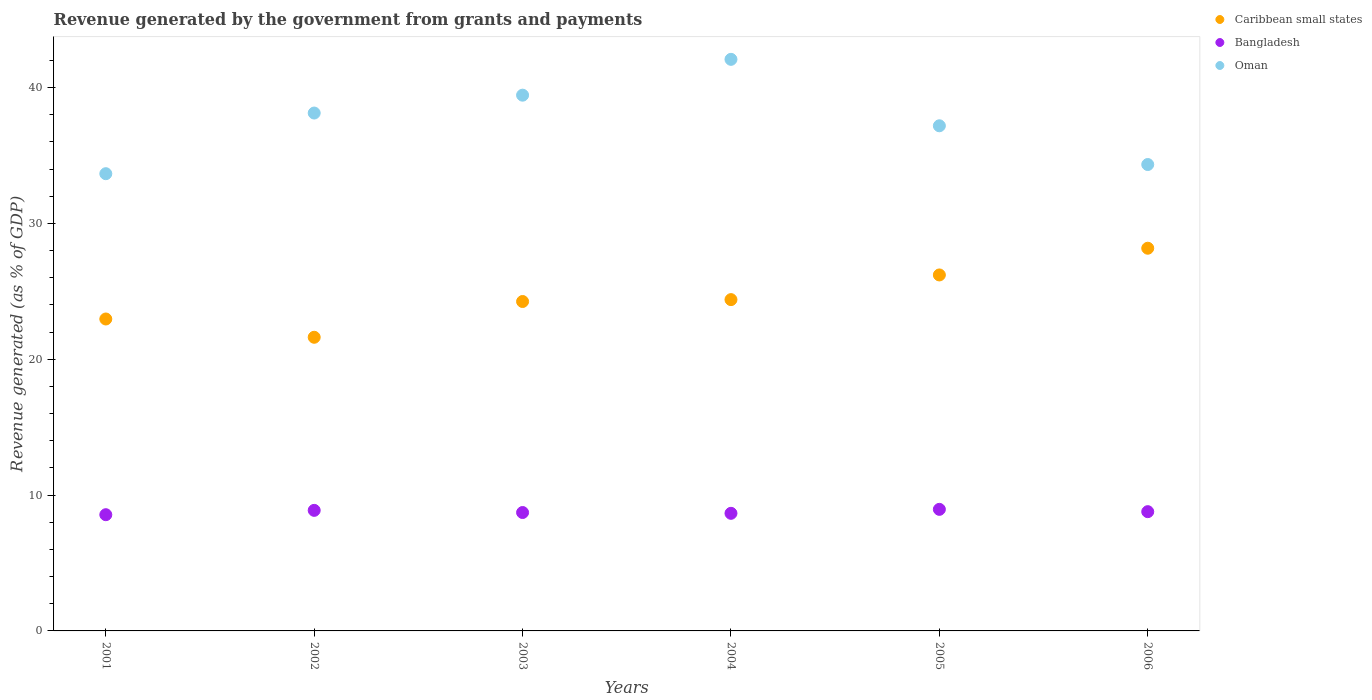How many different coloured dotlines are there?
Offer a terse response. 3. Is the number of dotlines equal to the number of legend labels?
Keep it short and to the point. Yes. What is the revenue generated by the government in Caribbean small states in 2004?
Give a very brief answer. 24.39. Across all years, what is the maximum revenue generated by the government in Oman?
Provide a short and direct response. 42.07. Across all years, what is the minimum revenue generated by the government in Caribbean small states?
Your answer should be very brief. 21.62. In which year was the revenue generated by the government in Oman minimum?
Your answer should be very brief. 2001. What is the total revenue generated by the government in Caribbean small states in the graph?
Provide a succinct answer. 147.59. What is the difference between the revenue generated by the government in Caribbean small states in 2005 and that in 2006?
Ensure brevity in your answer.  -1.97. What is the difference between the revenue generated by the government in Oman in 2001 and the revenue generated by the government in Bangladesh in 2005?
Provide a short and direct response. 24.71. What is the average revenue generated by the government in Bangladesh per year?
Ensure brevity in your answer.  8.75. In the year 2005, what is the difference between the revenue generated by the government in Bangladesh and revenue generated by the government in Caribbean small states?
Your response must be concise. -17.25. In how many years, is the revenue generated by the government in Oman greater than 12 %?
Give a very brief answer. 6. What is the ratio of the revenue generated by the government in Bangladesh in 2002 to that in 2006?
Your response must be concise. 1.01. Is the revenue generated by the government in Caribbean small states in 2003 less than that in 2005?
Provide a short and direct response. Yes. Is the difference between the revenue generated by the government in Bangladesh in 2003 and 2005 greater than the difference between the revenue generated by the government in Caribbean small states in 2003 and 2005?
Keep it short and to the point. Yes. What is the difference between the highest and the second highest revenue generated by the government in Caribbean small states?
Your response must be concise. 1.97. What is the difference between the highest and the lowest revenue generated by the government in Oman?
Make the answer very short. 8.42. Is it the case that in every year, the sum of the revenue generated by the government in Bangladesh and revenue generated by the government in Caribbean small states  is greater than the revenue generated by the government in Oman?
Make the answer very short. No. Does the revenue generated by the government in Caribbean small states monotonically increase over the years?
Your answer should be compact. No. How many years are there in the graph?
Your response must be concise. 6. Are the values on the major ticks of Y-axis written in scientific E-notation?
Ensure brevity in your answer.  No. What is the title of the graph?
Give a very brief answer. Revenue generated by the government from grants and payments. Does "Sub-Saharan Africa (developing only)" appear as one of the legend labels in the graph?
Give a very brief answer. No. What is the label or title of the Y-axis?
Provide a short and direct response. Revenue generated (as % of GDP). What is the Revenue generated (as % of GDP) in Caribbean small states in 2001?
Offer a very short reply. 22.96. What is the Revenue generated (as % of GDP) of Bangladesh in 2001?
Your response must be concise. 8.56. What is the Revenue generated (as % of GDP) in Oman in 2001?
Provide a short and direct response. 33.66. What is the Revenue generated (as % of GDP) of Caribbean small states in 2002?
Offer a terse response. 21.62. What is the Revenue generated (as % of GDP) in Bangladesh in 2002?
Give a very brief answer. 8.87. What is the Revenue generated (as % of GDP) of Oman in 2002?
Your answer should be very brief. 38.12. What is the Revenue generated (as % of GDP) in Caribbean small states in 2003?
Keep it short and to the point. 24.25. What is the Revenue generated (as % of GDP) of Bangladesh in 2003?
Your answer should be very brief. 8.72. What is the Revenue generated (as % of GDP) in Oman in 2003?
Ensure brevity in your answer.  39.44. What is the Revenue generated (as % of GDP) of Caribbean small states in 2004?
Offer a very short reply. 24.39. What is the Revenue generated (as % of GDP) of Bangladesh in 2004?
Offer a very short reply. 8.66. What is the Revenue generated (as % of GDP) of Oman in 2004?
Give a very brief answer. 42.07. What is the Revenue generated (as % of GDP) of Caribbean small states in 2005?
Ensure brevity in your answer.  26.2. What is the Revenue generated (as % of GDP) of Bangladesh in 2005?
Your answer should be very brief. 8.95. What is the Revenue generated (as % of GDP) of Oman in 2005?
Your response must be concise. 37.18. What is the Revenue generated (as % of GDP) of Caribbean small states in 2006?
Make the answer very short. 28.17. What is the Revenue generated (as % of GDP) of Bangladesh in 2006?
Provide a succinct answer. 8.78. What is the Revenue generated (as % of GDP) of Oman in 2006?
Offer a very short reply. 34.33. Across all years, what is the maximum Revenue generated (as % of GDP) in Caribbean small states?
Give a very brief answer. 28.17. Across all years, what is the maximum Revenue generated (as % of GDP) in Bangladesh?
Offer a very short reply. 8.95. Across all years, what is the maximum Revenue generated (as % of GDP) in Oman?
Offer a very short reply. 42.07. Across all years, what is the minimum Revenue generated (as % of GDP) in Caribbean small states?
Ensure brevity in your answer.  21.62. Across all years, what is the minimum Revenue generated (as % of GDP) of Bangladesh?
Make the answer very short. 8.56. Across all years, what is the minimum Revenue generated (as % of GDP) of Oman?
Keep it short and to the point. 33.66. What is the total Revenue generated (as % of GDP) of Caribbean small states in the graph?
Give a very brief answer. 147.59. What is the total Revenue generated (as % of GDP) of Bangladesh in the graph?
Provide a succinct answer. 52.53. What is the total Revenue generated (as % of GDP) in Oman in the graph?
Offer a terse response. 224.81. What is the difference between the Revenue generated (as % of GDP) of Caribbean small states in 2001 and that in 2002?
Make the answer very short. 1.35. What is the difference between the Revenue generated (as % of GDP) of Bangladesh in 2001 and that in 2002?
Keep it short and to the point. -0.32. What is the difference between the Revenue generated (as % of GDP) in Oman in 2001 and that in 2002?
Provide a short and direct response. -4.46. What is the difference between the Revenue generated (as % of GDP) of Caribbean small states in 2001 and that in 2003?
Provide a short and direct response. -1.29. What is the difference between the Revenue generated (as % of GDP) of Bangladesh in 2001 and that in 2003?
Make the answer very short. -0.16. What is the difference between the Revenue generated (as % of GDP) of Oman in 2001 and that in 2003?
Provide a short and direct response. -5.78. What is the difference between the Revenue generated (as % of GDP) in Caribbean small states in 2001 and that in 2004?
Provide a short and direct response. -1.43. What is the difference between the Revenue generated (as % of GDP) in Bangladesh in 2001 and that in 2004?
Your answer should be compact. -0.1. What is the difference between the Revenue generated (as % of GDP) in Oman in 2001 and that in 2004?
Offer a terse response. -8.42. What is the difference between the Revenue generated (as % of GDP) in Caribbean small states in 2001 and that in 2005?
Ensure brevity in your answer.  -3.24. What is the difference between the Revenue generated (as % of GDP) in Bangladesh in 2001 and that in 2005?
Your answer should be very brief. -0.39. What is the difference between the Revenue generated (as % of GDP) in Oman in 2001 and that in 2005?
Ensure brevity in your answer.  -3.53. What is the difference between the Revenue generated (as % of GDP) in Caribbean small states in 2001 and that in 2006?
Offer a very short reply. -5.21. What is the difference between the Revenue generated (as % of GDP) in Bangladesh in 2001 and that in 2006?
Your response must be concise. -0.22. What is the difference between the Revenue generated (as % of GDP) of Oman in 2001 and that in 2006?
Your response must be concise. -0.68. What is the difference between the Revenue generated (as % of GDP) of Caribbean small states in 2002 and that in 2003?
Offer a terse response. -2.63. What is the difference between the Revenue generated (as % of GDP) of Bangladesh in 2002 and that in 2003?
Provide a short and direct response. 0.16. What is the difference between the Revenue generated (as % of GDP) of Oman in 2002 and that in 2003?
Offer a very short reply. -1.32. What is the difference between the Revenue generated (as % of GDP) of Caribbean small states in 2002 and that in 2004?
Offer a terse response. -2.77. What is the difference between the Revenue generated (as % of GDP) of Bangladesh in 2002 and that in 2004?
Your response must be concise. 0.22. What is the difference between the Revenue generated (as % of GDP) of Oman in 2002 and that in 2004?
Provide a short and direct response. -3.95. What is the difference between the Revenue generated (as % of GDP) in Caribbean small states in 2002 and that in 2005?
Offer a very short reply. -4.59. What is the difference between the Revenue generated (as % of GDP) in Bangladesh in 2002 and that in 2005?
Make the answer very short. -0.07. What is the difference between the Revenue generated (as % of GDP) of Oman in 2002 and that in 2005?
Your response must be concise. 0.94. What is the difference between the Revenue generated (as % of GDP) of Caribbean small states in 2002 and that in 2006?
Provide a short and direct response. -6.55. What is the difference between the Revenue generated (as % of GDP) of Bangladesh in 2002 and that in 2006?
Offer a terse response. 0.1. What is the difference between the Revenue generated (as % of GDP) in Oman in 2002 and that in 2006?
Your answer should be compact. 3.79. What is the difference between the Revenue generated (as % of GDP) in Caribbean small states in 2003 and that in 2004?
Provide a succinct answer. -0.14. What is the difference between the Revenue generated (as % of GDP) in Bangladesh in 2003 and that in 2004?
Provide a short and direct response. 0.06. What is the difference between the Revenue generated (as % of GDP) in Oman in 2003 and that in 2004?
Your response must be concise. -2.64. What is the difference between the Revenue generated (as % of GDP) of Caribbean small states in 2003 and that in 2005?
Your answer should be compact. -1.96. What is the difference between the Revenue generated (as % of GDP) of Bangladesh in 2003 and that in 2005?
Provide a succinct answer. -0.23. What is the difference between the Revenue generated (as % of GDP) of Oman in 2003 and that in 2005?
Offer a terse response. 2.25. What is the difference between the Revenue generated (as % of GDP) in Caribbean small states in 2003 and that in 2006?
Offer a very short reply. -3.92. What is the difference between the Revenue generated (as % of GDP) of Bangladesh in 2003 and that in 2006?
Offer a terse response. -0.06. What is the difference between the Revenue generated (as % of GDP) in Oman in 2003 and that in 2006?
Provide a short and direct response. 5.11. What is the difference between the Revenue generated (as % of GDP) in Caribbean small states in 2004 and that in 2005?
Your response must be concise. -1.82. What is the difference between the Revenue generated (as % of GDP) in Bangladesh in 2004 and that in 2005?
Your answer should be very brief. -0.29. What is the difference between the Revenue generated (as % of GDP) in Oman in 2004 and that in 2005?
Offer a terse response. 4.89. What is the difference between the Revenue generated (as % of GDP) of Caribbean small states in 2004 and that in 2006?
Offer a terse response. -3.78. What is the difference between the Revenue generated (as % of GDP) in Bangladesh in 2004 and that in 2006?
Offer a very short reply. -0.12. What is the difference between the Revenue generated (as % of GDP) of Oman in 2004 and that in 2006?
Give a very brief answer. 7.74. What is the difference between the Revenue generated (as % of GDP) in Caribbean small states in 2005 and that in 2006?
Offer a terse response. -1.97. What is the difference between the Revenue generated (as % of GDP) of Bangladesh in 2005 and that in 2006?
Your response must be concise. 0.17. What is the difference between the Revenue generated (as % of GDP) in Oman in 2005 and that in 2006?
Your answer should be very brief. 2.85. What is the difference between the Revenue generated (as % of GDP) in Caribbean small states in 2001 and the Revenue generated (as % of GDP) in Bangladesh in 2002?
Keep it short and to the point. 14.09. What is the difference between the Revenue generated (as % of GDP) of Caribbean small states in 2001 and the Revenue generated (as % of GDP) of Oman in 2002?
Provide a succinct answer. -15.16. What is the difference between the Revenue generated (as % of GDP) in Bangladesh in 2001 and the Revenue generated (as % of GDP) in Oman in 2002?
Provide a short and direct response. -29.57. What is the difference between the Revenue generated (as % of GDP) of Caribbean small states in 2001 and the Revenue generated (as % of GDP) of Bangladesh in 2003?
Your answer should be very brief. 14.25. What is the difference between the Revenue generated (as % of GDP) in Caribbean small states in 2001 and the Revenue generated (as % of GDP) in Oman in 2003?
Offer a very short reply. -16.48. What is the difference between the Revenue generated (as % of GDP) in Bangladesh in 2001 and the Revenue generated (as % of GDP) in Oman in 2003?
Offer a very short reply. -30.88. What is the difference between the Revenue generated (as % of GDP) of Caribbean small states in 2001 and the Revenue generated (as % of GDP) of Bangladesh in 2004?
Make the answer very short. 14.3. What is the difference between the Revenue generated (as % of GDP) of Caribbean small states in 2001 and the Revenue generated (as % of GDP) of Oman in 2004?
Ensure brevity in your answer.  -19.11. What is the difference between the Revenue generated (as % of GDP) in Bangladesh in 2001 and the Revenue generated (as % of GDP) in Oman in 2004?
Make the answer very short. -33.52. What is the difference between the Revenue generated (as % of GDP) in Caribbean small states in 2001 and the Revenue generated (as % of GDP) in Bangladesh in 2005?
Give a very brief answer. 14.01. What is the difference between the Revenue generated (as % of GDP) of Caribbean small states in 2001 and the Revenue generated (as % of GDP) of Oman in 2005?
Ensure brevity in your answer.  -14.22. What is the difference between the Revenue generated (as % of GDP) in Bangladesh in 2001 and the Revenue generated (as % of GDP) in Oman in 2005?
Make the answer very short. -28.63. What is the difference between the Revenue generated (as % of GDP) in Caribbean small states in 2001 and the Revenue generated (as % of GDP) in Bangladesh in 2006?
Your response must be concise. 14.18. What is the difference between the Revenue generated (as % of GDP) of Caribbean small states in 2001 and the Revenue generated (as % of GDP) of Oman in 2006?
Keep it short and to the point. -11.37. What is the difference between the Revenue generated (as % of GDP) of Bangladesh in 2001 and the Revenue generated (as % of GDP) of Oman in 2006?
Your answer should be compact. -25.78. What is the difference between the Revenue generated (as % of GDP) in Caribbean small states in 2002 and the Revenue generated (as % of GDP) in Bangladesh in 2003?
Provide a short and direct response. 12.9. What is the difference between the Revenue generated (as % of GDP) of Caribbean small states in 2002 and the Revenue generated (as % of GDP) of Oman in 2003?
Make the answer very short. -17.82. What is the difference between the Revenue generated (as % of GDP) in Bangladesh in 2002 and the Revenue generated (as % of GDP) in Oman in 2003?
Give a very brief answer. -30.56. What is the difference between the Revenue generated (as % of GDP) in Caribbean small states in 2002 and the Revenue generated (as % of GDP) in Bangladesh in 2004?
Make the answer very short. 12.96. What is the difference between the Revenue generated (as % of GDP) of Caribbean small states in 2002 and the Revenue generated (as % of GDP) of Oman in 2004?
Keep it short and to the point. -20.46. What is the difference between the Revenue generated (as % of GDP) in Bangladesh in 2002 and the Revenue generated (as % of GDP) in Oman in 2004?
Ensure brevity in your answer.  -33.2. What is the difference between the Revenue generated (as % of GDP) in Caribbean small states in 2002 and the Revenue generated (as % of GDP) in Bangladesh in 2005?
Offer a very short reply. 12.67. What is the difference between the Revenue generated (as % of GDP) in Caribbean small states in 2002 and the Revenue generated (as % of GDP) in Oman in 2005?
Provide a short and direct response. -15.57. What is the difference between the Revenue generated (as % of GDP) in Bangladesh in 2002 and the Revenue generated (as % of GDP) in Oman in 2005?
Ensure brevity in your answer.  -28.31. What is the difference between the Revenue generated (as % of GDP) of Caribbean small states in 2002 and the Revenue generated (as % of GDP) of Bangladesh in 2006?
Offer a terse response. 12.84. What is the difference between the Revenue generated (as % of GDP) in Caribbean small states in 2002 and the Revenue generated (as % of GDP) in Oman in 2006?
Keep it short and to the point. -12.72. What is the difference between the Revenue generated (as % of GDP) of Bangladesh in 2002 and the Revenue generated (as % of GDP) of Oman in 2006?
Offer a very short reply. -25.46. What is the difference between the Revenue generated (as % of GDP) of Caribbean small states in 2003 and the Revenue generated (as % of GDP) of Bangladesh in 2004?
Your answer should be very brief. 15.59. What is the difference between the Revenue generated (as % of GDP) of Caribbean small states in 2003 and the Revenue generated (as % of GDP) of Oman in 2004?
Make the answer very short. -17.83. What is the difference between the Revenue generated (as % of GDP) in Bangladesh in 2003 and the Revenue generated (as % of GDP) in Oman in 2004?
Provide a succinct answer. -33.36. What is the difference between the Revenue generated (as % of GDP) in Caribbean small states in 2003 and the Revenue generated (as % of GDP) in Bangladesh in 2005?
Provide a succinct answer. 15.3. What is the difference between the Revenue generated (as % of GDP) in Caribbean small states in 2003 and the Revenue generated (as % of GDP) in Oman in 2005?
Your answer should be compact. -12.93. What is the difference between the Revenue generated (as % of GDP) of Bangladesh in 2003 and the Revenue generated (as % of GDP) of Oman in 2005?
Make the answer very short. -28.47. What is the difference between the Revenue generated (as % of GDP) of Caribbean small states in 2003 and the Revenue generated (as % of GDP) of Bangladesh in 2006?
Provide a short and direct response. 15.47. What is the difference between the Revenue generated (as % of GDP) in Caribbean small states in 2003 and the Revenue generated (as % of GDP) in Oman in 2006?
Your answer should be compact. -10.08. What is the difference between the Revenue generated (as % of GDP) in Bangladesh in 2003 and the Revenue generated (as % of GDP) in Oman in 2006?
Your answer should be very brief. -25.62. What is the difference between the Revenue generated (as % of GDP) of Caribbean small states in 2004 and the Revenue generated (as % of GDP) of Bangladesh in 2005?
Keep it short and to the point. 15.44. What is the difference between the Revenue generated (as % of GDP) in Caribbean small states in 2004 and the Revenue generated (as % of GDP) in Oman in 2005?
Your answer should be compact. -12.8. What is the difference between the Revenue generated (as % of GDP) in Bangladesh in 2004 and the Revenue generated (as % of GDP) in Oman in 2005?
Ensure brevity in your answer.  -28.53. What is the difference between the Revenue generated (as % of GDP) of Caribbean small states in 2004 and the Revenue generated (as % of GDP) of Bangladesh in 2006?
Offer a terse response. 15.61. What is the difference between the Revenue generated (as % of GDP) of Caribbean small states in 2004 and the Revenue generated (as % of GDP) of Oman in 2006?
Your answer should be compact. -9.94. What is the difference between the Revenue generated (as % of GDP) in Bangladesh in 2004 and the Revenue generated (as % of GDP) in Oman in 2006?
Offer a terse response. -25.68. What is the difference between the Revenue generated (as % of GDP) in Caribbean small states in 2005 and the Revenue generated (as % of GDP) in Bangladesh in 2006?
Offer a terse response. 17.43. What is the difference between the Revenue generated (as % of GDP) in Caribbean small states in 2005 and the Revenue generated (as % of GDP) in Oman in 2006?
Your answer should be very brief. -8.13. What is the difference between the Revenue generated (as % of GDP) in Bangladesh in 2005 and the Revenue generated (as % of GDP) in Oman in 2006?
Your response must be concise. -25.38. What is the average Revenue generated (as % of GDP) of Caribbean small states per year?
Your answer should be compact. 24.6. What is the average Revenue generated (as % of GDP) of Bangladesh per year?
Give a very brief answer. 8.75. What is the average Revenue generated (as % of GDP) in Oman per year?
Ensure brevity in your answer.  37.47. In the year 2001, what is the difference between the Revenue generated (as % of GDP) of Caribbean small states and Revenue generated (as % of GDP) of Bangladesh?
Give a very brief answer. 14.41. In the year 2001, what is the difference between the Revenue generated (as % of GDP) in Caribbean small states and Revenue generated (as % of GDP) in Oman?
Provide a short and direct response. -10.7. In the year 2001, what is the difference between the Revenue generated (as % of GDP) in Bangladesh and Revenue generated (as % of GDP) in Oman?
Give a very brief answer. -25.1. In the year 2002, what is the difference between the Revenue generated (as % of GDP) in Caribbean small states and Revenue generated (as % of GDP) in Bangladesh?
Your answer should be very brief. 12.74. In the year 2002, what is the difference between the Revenue generated (as % of GDP) of Caribbean small states and Revenue generated (as % of GDP) of Oman?
Your response must be concise. -16.51. In the year 2002, what is the difference between the Revenue generated (as % of GDP) in Bangladesh and Revenue generated (as % of GDP) in Oman?
Give a very brief answer. -29.25. In the year 2003, what is the difference between the Revenue generated (as % of GDP) in Caribbean small states and Revenue generated (as % of GDP) in Bangladesh?
Provide a short and direct response. 15.53. In the year 2003, what is the difference between the Revenue generated (as % of GDP) in Caribbean small states and Revenue generated (as % of GDP) in Oman?
Keep it short and to the point. -15.19. In the year 2003, what is the difference between the Revenue generated (as % of GDP) in Bangladesh and Revenue generated (as % of GDP) in Oman?
Offer a very short reply. -30.72. In the year 2004, what is the difference between the Revenue generated (as % of GDP) of Caribbean small states and Revenue generated (as % of GDP) of Bangladesh?
Your answer should be very brief. 15.73. In the year 2004, what is the difference between the Revenue generated (as % of GDP) of Caribbean small states and Revenue generated (as % of GDP) of Oman?
Give a very brief answer. -17.69. In the year 2004, what is the difference between the Revenue generated (as % of GDP) of Bangladesh and Revenue generated (as % of GDP) of Oman?
Your answer should be very brief. -33.42. In the year 2005, what is the difference between the Revenue generated (as % of GDP) in Caribbean small states and Revenue generated (as % of GDP) in Bangladesh?
Offer a terse response. 17.25. In the year 2005, what is the difference between the Revenue generated (as % of GDP) of Caribbean small states and Revenue generated (as % of GDP) of Oman?
Your answer should be very brief. -10.98. In the year 2005, what is the difference between the Revenue generated (as % of GDP) in Bangladesh and Revenue generated (as % of GDP) in Oman?
Your response must be concise. -28.23. In the year 2006, what is the difference between the Revenue generated (as % of GDP) in Caribbean small states and Revenue generated (as % of GDP) in Bangladesh?
Make the answer very short. 19.39. In the year 2006, what is the difference between the Revenue generated (as % of GDP) of Caribbean small states and Revenue generated (as % of GDP) of Oman?
Offer a very short reply. -6.16. In the year 2006, what is the difference between the Revenue generated (as % of GDP) in Bangladesh and Revenue generated (as % of GDP) in Oman?
Give a very brief answer. -25.55. What is the ratio of the Revenue generated (as % of GDP) in Caribbean small states in 2001 to that in 2002?
Your response must be concise. 1.06. What is the ratio of the Revenue generated (as % of GDP) of Oman in 2001 to that in 2002?
Give a very brief answer. 0.88. What is the ratio of the Revenue generated (as % of GDP) in Caribbean small states in 2001 to that in 2003?
Offer a terse response. 0.95. What is the ratio of the Revenue generated (as % of GDP) of Bangladesh in 2001 to that in 2003?
Provide a succinct answer. 0.98. What is the ratio of the Revenue generated (as % of GDP) of Oman in 2001 to that in 2003?
Provide a succinct answer. 0.85. What is the ratio of the Revenue generated (as % of GDP) of Caribbean small states in 2001 to that in 2004?
Your answer should be compact. 0.94. What is the ratio of the Revenue generated (as % of GDP) in Bangladesh in 2001 to that in 2004?
Offer a very short reply. 0.99. What is the ratio of the Revenue generated (as % of GDP) of Oman in 2001 to that in 2004?
Provide a succinct answer. 0.8. What is the ratio of the Revenue generated (as % of GDP) in Caribbean small states in 2001 to that in 2005?
Your response must be concise. 0.88. What is the ratio of the Revenue generated (as % of GDP) of Bangladesh in 2001 to that in 2005?
Your response must be concise. 0.96. What is the ratio of the Revenue generated (as % of GDP) in Oman in 2001 to that in 2005?
Make the answer very short. 0.91. What is the ratio of the Revenue generated (as % of GDP) of Caribbean small states in 2001 to that in 2006?
Provide a short and direct response. 0.82. What is the ratio of the Revenue generated (as % of GDP) in Bangladesh in 2001 to that in 2006?
Offer a terse response. 0.97. What is the ratio of the Revenue generated (as % of GDP) in Oman in 2001 to that in 2006?
Your answer should be very brief. 0.98. What is the ratio of the Revenue generated (as % of GDP) of Caribbean small states in 2002 to that in 2003?
Make the answer very short. 0.89. What is the ratio of the Revenue generated (as % of GDP) of Bangladesh in 2002 to that in 2003?
Keep it short and to the point. 1.02. What is the ratio of the Revenue generated (as % of GDP) of Oman in 2002 to that in 2003?
Your answer should be compact. 0.97. What is the ratio of the Revenue generated (as % of GDP) in Caribbean small states in 2002 to that in 2004?
Ensure brevity in your answer.  0.89. What is the ratio of the Revenue generated (as % of GDP) in Bangladesh in 2002 to that in 2004?
Provide a succinct answer. 1.03. What is the ratio of the Revenue generated (as % of GDP) of Oman in 2002 to that in 2004?
Your response must be concise. 0.91. What is the ratio of the Revenue generated (as % of GDP) in Caribbean small states in 2002 to that in 2005?
Keep it short and to the point. 0.82. What is the ratio of the Revenue generated (as % of GDP) in Bangladesh in 2002 to that in 2005?
Offer a terse response. 0.99. What is the ratio of the Revenue generated (as % of GDP) in Oman in 2002 to that in 2005?
Ensure brevity in your answer.  1.03. What is the ratio of the Revenue generated (as % of GDP) in Caribbean small states in 2002 to that in 2006?
Your answer should be compact. 0.77. What is the ratio of the Revenue generated (as % of GDP) of Bangladesh in 2002 to that in 2006?
Ensure brevity in your answer.  1.01. What is the ratio of the Revenue generated (as % of GDP) in Oman in 2002 to that in 2006?
Offer a terse response. 1.11. What is the ratio of the Revenue generated (as % of GDP) in Bangladesh in 2003 to that in 2004?
Your answer should be very brief. 1.01. What is the ratio of the Revenue generated (as % of GDP) in Oman in 2003 to that in 2004?
Your answer should be compact. 0.94. What is the ratio of the Revenue generated (as % of GDP) in Caribbean small states in 2003 to that in 2005?
Ensure brevity in your answer.  0.93. What is the ratio of the Revenue generated (as % of GDP) of Bangladesh in 2003 to that in 2005?
Keep it short and to the point. 0.97. What is the ratio of the Revenue generated (as % of GDP) in Oman in 2003 to that in 2005?
Ensure brevity in your answer.  1.06. What is the ratio of the Revenue generated (as % of GDP) in Caribbean small states in 2003 to that in 2006?
Offer a very short reply. 0.86. What is the ratio of the Revenue generated (as % of GDP) in Bangladesh in 2003 to that in 2006?
Offer a terse response. 0.99. What is the ratio of the Revenue generated (as % of GDP) in Oman in 2003 to that in 2006?
Offer a very short reply. 1.15. What is the ratio of the Revenue generated (as % of GDP) of Caribbean small states in 2004 to that in 2005?
Offer a very short reply. 0.93. What is the ratio of the Revenue generated (as % of GDP) of Bangladesh in 2004 to that in 2005?
Offer a very short reply. 0.97. What is the ratio of the Revenue generated (as % of GDP) of Oman in 2004 to that in 2005?
Make the answer very short. 1.13. What is the ratio of the Revenue generated (as % of GDP) in Caribbean small states in 2004 to that in 2006?
Your answer should be very brief. 0.87. What is the ratio of the Revenue generated (as % of GDP) in Bangladesh in 2004 to that in 2006?
Give a very brief answer. 0.99. What is the ratio of the Revenue generated (as % of GDP) of Oman in 2004 to that in 2006?
Give a very brief answer. 1.23. What is the ratio of the Revenue generated (as % of GDP) of Caribbean small states in 2005 to that in 2006?
Your response must be concise. 0.93. What is the ratio of the Revenue generated (as % of GDP) of Bangladesh in 2005 to that in 2006?
Your answer should be very brief. 1.02. What is the ratio of the Revenue generated (as % of GDP) in Oman in 2005 to that in 2006?
Provide a succinct answer. 1.08. What is the difference between the highest and the second highest Revenue generated (as % of GDP) of Caribbean small states?
Make the answer very short. 1.97. What is the difference between the highest and the second highest Revenue generated (as % of GDP) in Bangladesh?
Offer a terse response. 0.07. What is the difference between the highest and the second highest Revenue generated (as % of GDP) of Oman?
Offer a terse response. 2.64. What is the difference between the highest and the lowest Revenue generated (as % of GDP) in Caribbean small states?
Give a very brief answer. 6.55. What is the difference between the highest and the lowest Revenue generated (as % of GDP) in Bangladesh?
Your response must be concise. 0.39. What is the difference between the highest and the lowest Revenue generated (as % of GDP) in Oman?
Keep it short and to the point. 8.42. 